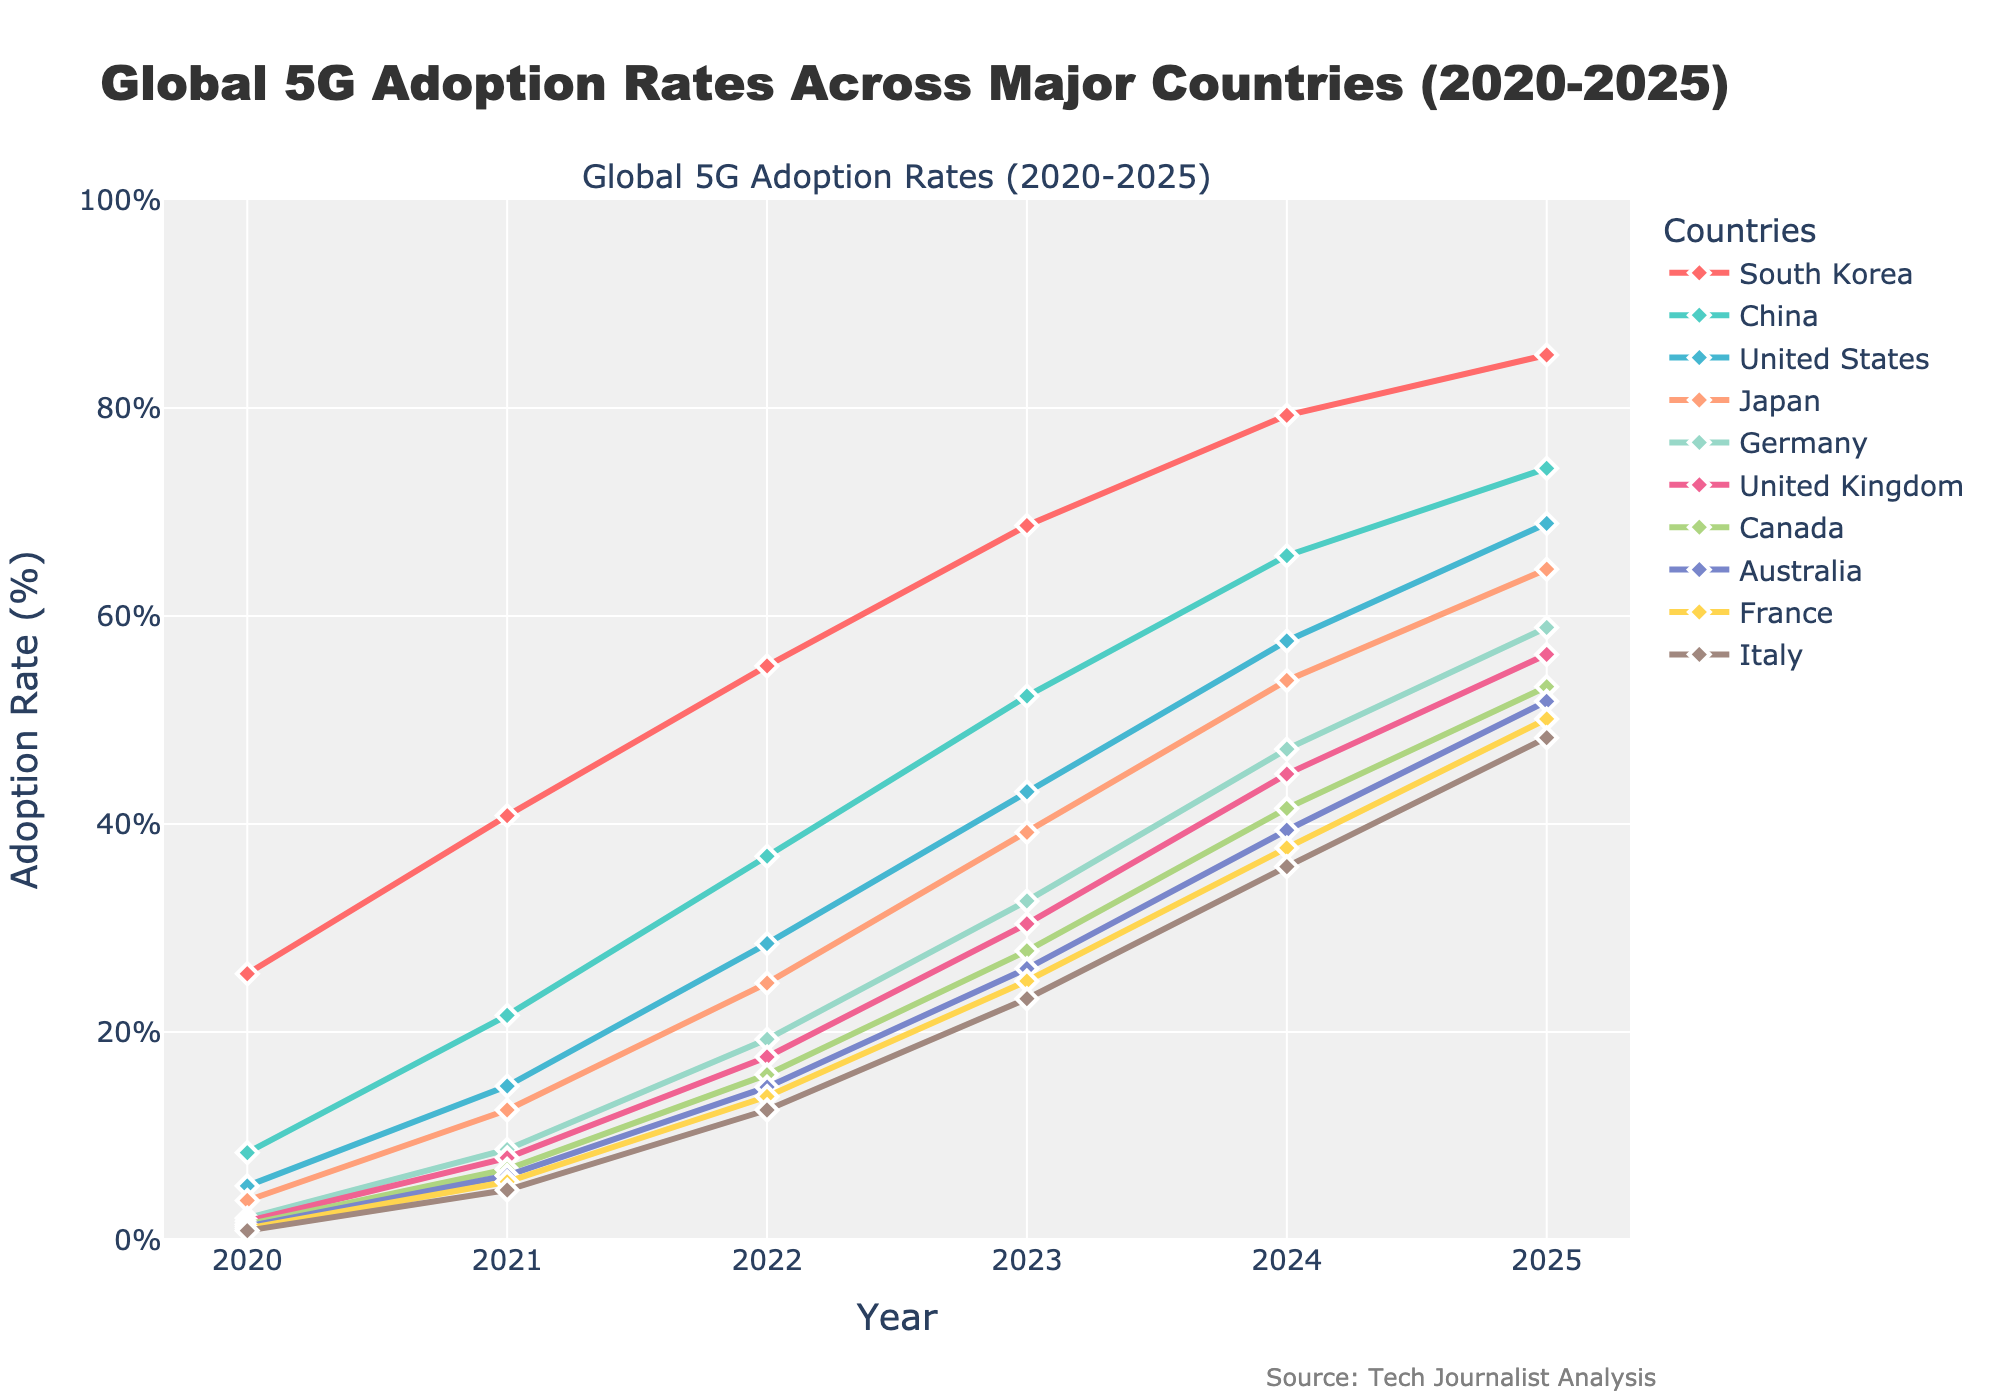what's the country with the highest 5G adoption rate in 2025? The highest 5G adoption rate in 2025 can be identified by looking at the end points of the lines on the graph in the year 2025. The country with the highest endpoint is South Korea.
Answer: South Korea what is the trend of 5G adoption in Japan from 2020 to 2025? The trend of 5G adoption in Japan can be observed by following the line representing Japan from 2020 to 2025. The adoption rate increases consistently each year from 3.8% in 2020 to 64.5% in 2025.
Answer: Increasing which country shows the smallest adoption rate increase from 2020 to 2021? By comparing the starting point (2020) and the first interval (2021) for each country, Italy has the smallest increase, moving from 0.9% in 2020 to 4.8% in 2021, an increase of 3.9 percentage points.
Answer: Italy how does the adoption rate of the United States in 2023 compare to that of Canada? In 2023, the adoption rate for the United States is 43.1%, and for Canada, it is 27.8%. The adoption rate in the United States is higher than that of Canada.
Answer: Higher which two countries have nearly equal adoption rates in 2025? By examining the end points in 2025, Germany and United Kingdom have nearly similar adoption rates with Germany at 58.9% and the United Kingdom at 56.3%.
Answer: Germany and United Kingdom what's the average 5G adoption rate across all countries in 2022? To find the average adoption rate in 2022, sum the adoption rates of all countries for that year and divide by the number of countries. (55.2 + 36.9 + 28.5 + 24.7 + 19.3 + 17.6 + 15.9 + 14.7 + 13.8 + 12.5)/10 = 23.91%
Answer: 23.91% between which years does France see its largest annual increase in adoption rate? Looking at the year-to-year increases for France, the largest increase happens between 2023 and 2024, going from 24.9% to 37.7%, an increase of 12.8 percentage points.
Answer: 2023 to 2024 how much higher is South Korea's adoption rate in 2025 compared to 2023? In 2025, South Korea has an adoption rate of 85.1%, and in 2023, it is 68.7%. The difference is 85.1 - 68.7 = 16.4 percentage points.
Answer: 16.4 percentage points which country shows a steeper increase from 2020 to 2025, China or the United States? Comparing the slopes of the lines for China and the United States, China's adoption rate goes from 8.4% to 74.2%, an increase of 65.8 percentage points, while the United States goes from 5.2% to 68.9%, an increase of 63.7 percentage points. Thus, China shows a steeper increase.
Answer: China what is the median 5G adoption rate for 2023? To find the median, list the adoption rates for 2023 in ascending order and find the middle value. The rates are 23.2, 24.9, 26.1, 27.8, 30.4, 32.6, 39.2, 43.1, 52.3, 68.7. The median is (30.4 + 32.6)/2 = 31.5%.
Answer: 31.5% 